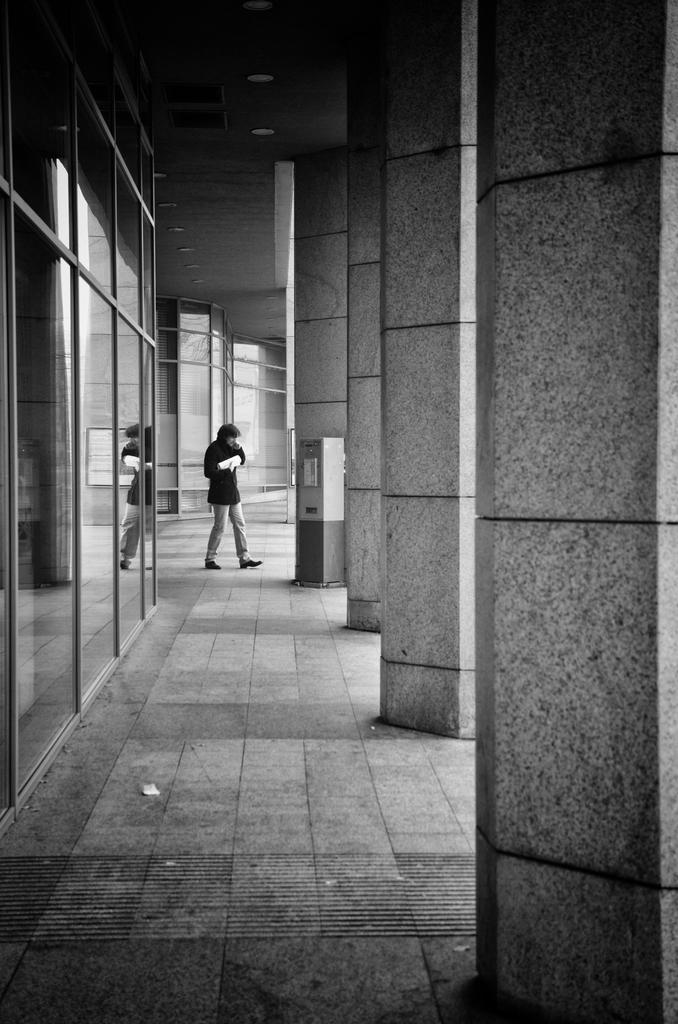Who or what is the main subject in the center of the image? There is a person in the center of the image. What architectural features can be seen in the image? There are pillars in the image. What type of doors are on the left side of the image? There are glass doors on the left side of the image. How many eggs are visible on the person's head in the image? There are no eggs visible on the person's head in the image. 